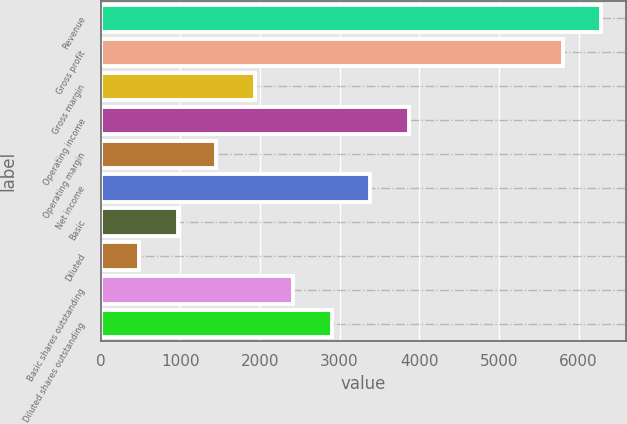Convert chart. <chart><loc_0><loc_0><loc_500><loc_500><bar_chart><fcel>Revenue<fcel>Gross profit<fcel>Gross margin<fcel>Operating income<fcel>Operating margin<fcel>Net income<fcel>Basic<fcel>Diluted<fcel>Basic shares outstanding<fcel>Diluted shares outstanding<nl><fcel>6282.76<fcel>5799.51<fcel>1933.51<fcel>3866.51<fcel>1450.26<fcel>3383.26<fcel>967.01<fcel>483.76<fcel>2416.76<fcel>2900.01<nl></chart> 